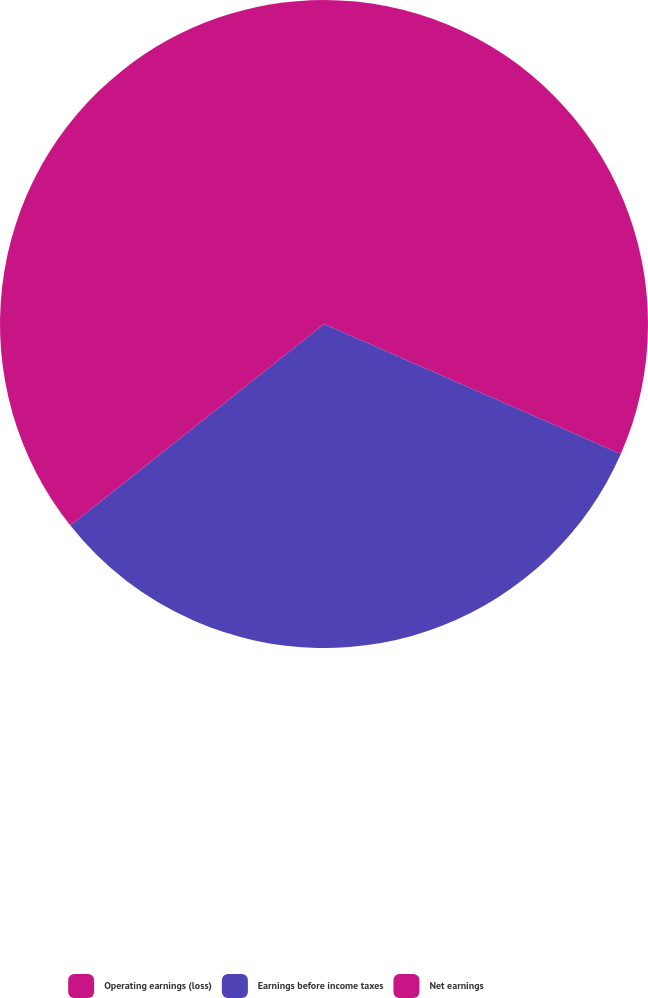Convert chart. <chart><loc_0><loc_0><loc_500><loc_500><pie_chart><fcel>Operating earnings (loss)<fcel>Earnings before income taxes<fcel>Net earnings<nl><fcel>31.57%<fcel>32.74%<fcel>35.69%<nl></chart> 